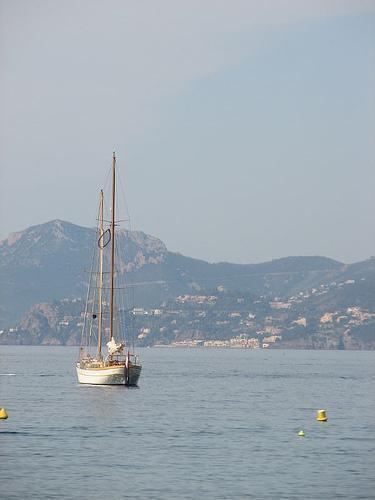How many birds are flying in this picture?
Give a very brief answer. 0. How many people are pictured here?
Give a very brief answer. 0. How many boats?
Give a very brief answer. 1. How many sailboats are pictured?
Give a very brief answer. 1. How many bears are in the chair?
Give a very brief answer. 0. 